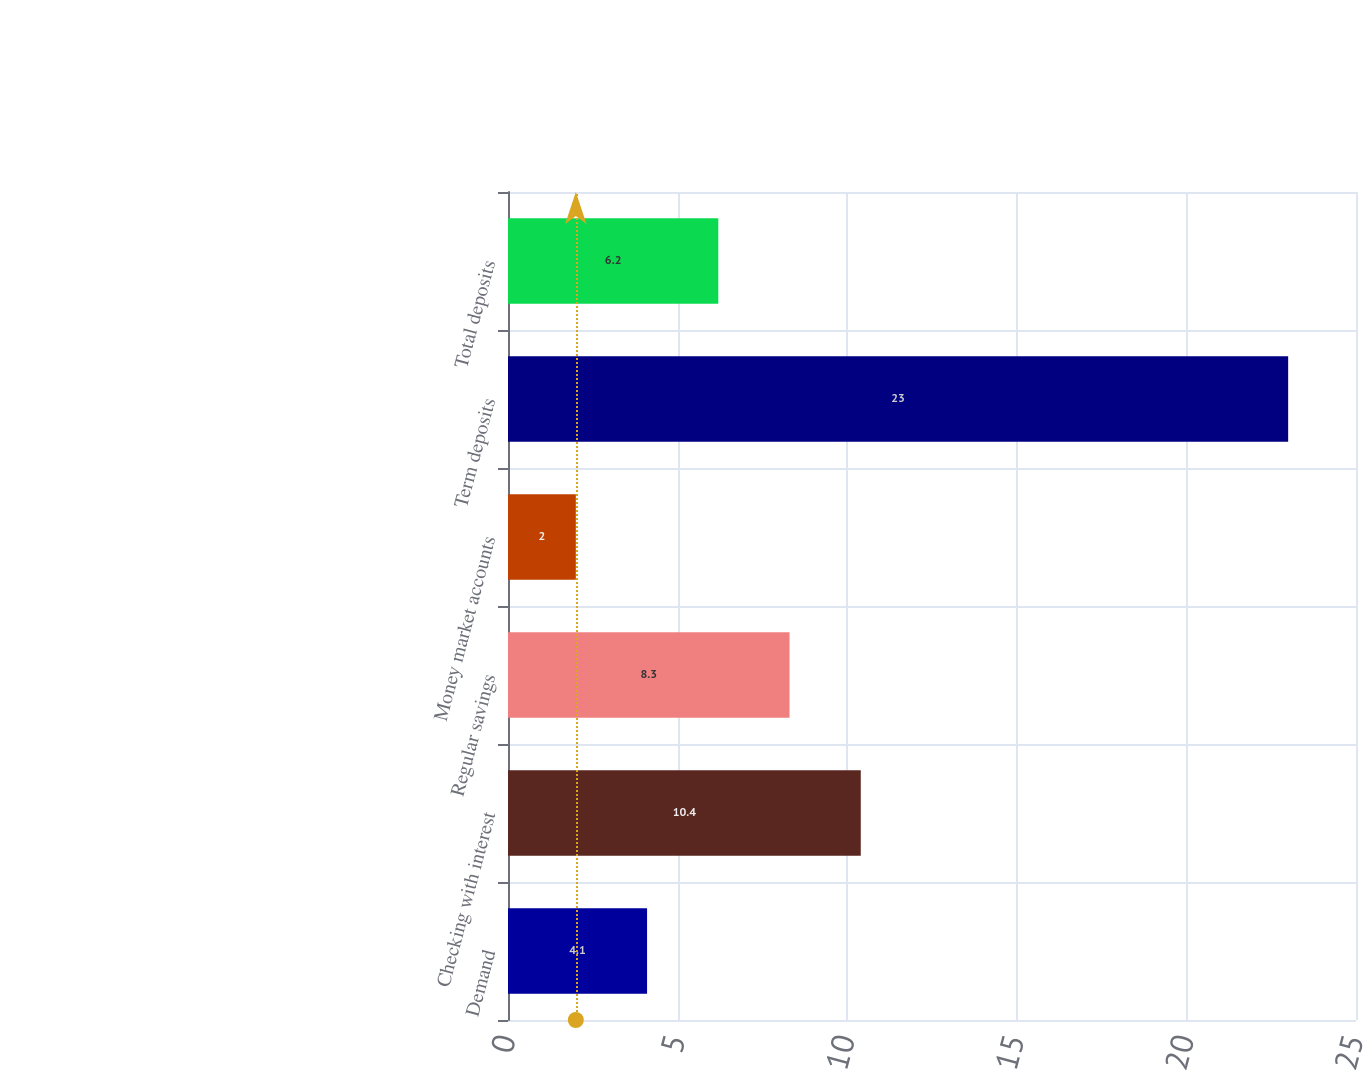Convert chart to OTSL. <chart><loc_0><loc_0><loc_500><loc_500><bar_chart><fcel>Demand<fcel>Checking with interest<fcel>Regular savings<fcel>Money market accounts<fcel>Term deposits<fcel>Total deposits<nl><fcel>4.1<fcel>10.4<fcel>8.3<fcel>2<fcel>23<fcel>6.2<nl></chart> 